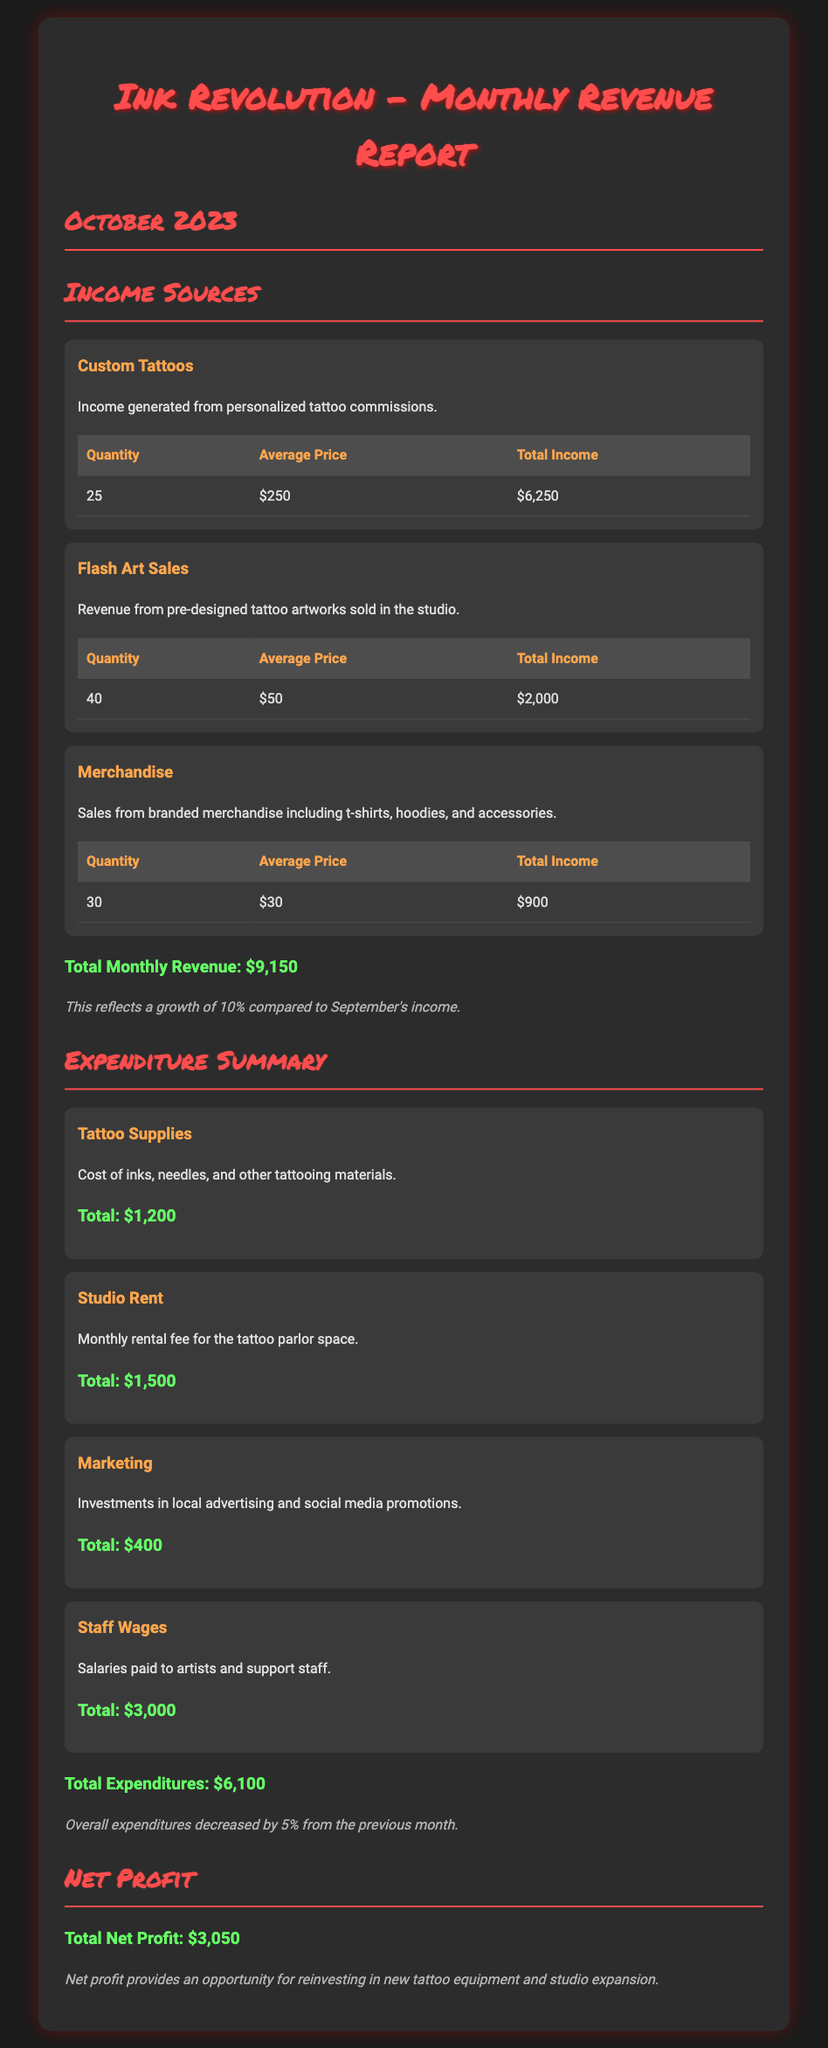what is the total monthly revenue? The total monthly revenue is found at the end of the income sources section, reflecting the sum of all income sources.
Answer: $9,150 how much did custom tattoos generate? The income from custom tattoos is detailed in the corresponding section with the total income listed.
Answer: $6,250 what is the quantity of flash art sold? The number of flash art pieces sold is provided in the table under the flash art sales section.
Answer: 40 what are the total expenditures? This is presented in the expenditure summary, detailing the total costs incurred for the month.
Answer: $6,100 what is the net profit for October 2023? The net profit is calculated by subtracting total expenditures from total monthly revenue, as stated in the document.
Answer: $3,050 how much was spent on staff wages? The total staff wages expense is located in the expenditure summary section of the document.
Answer: $3,000 what percentage growth did the revenue show compared to September? The document highlights the growth percentage in a note following the total revenue section.
Answer: 10% how much was allocated for marketing? The marketing expenditure is specified in the expenditure summary, indicating the total amount spent.
Answer: $400 what was the average price of merchandise sold? The average price of merchandise is indicated in the merchandise table under income sources.
Answer: $30 